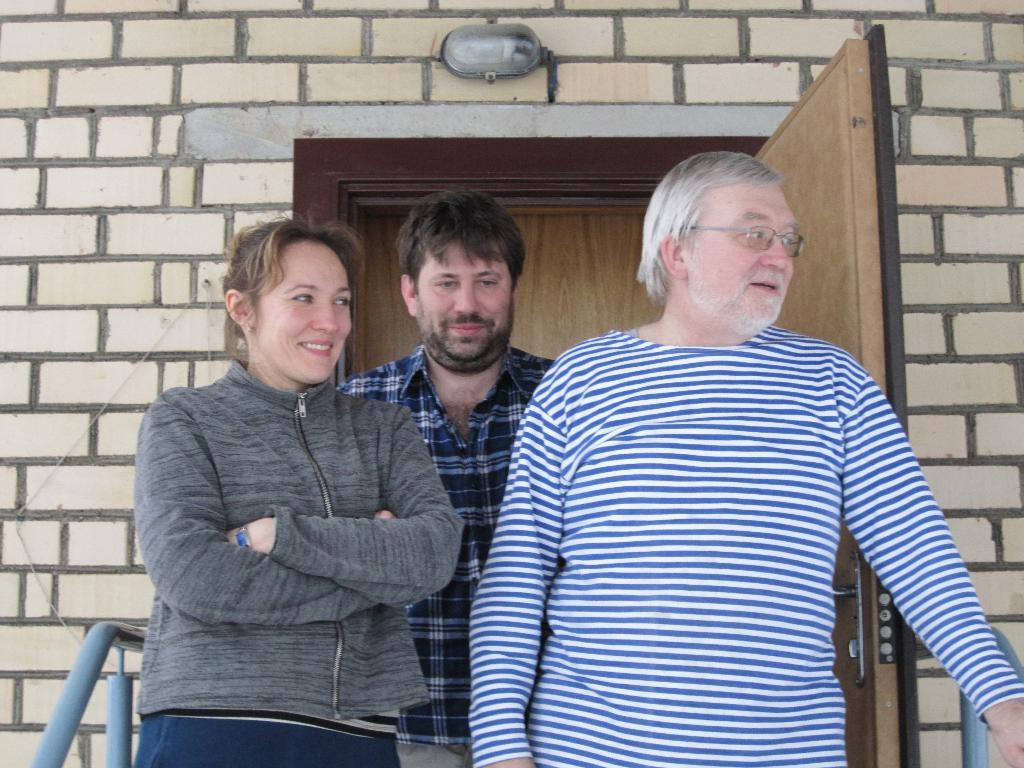How many people are in the image? There are three persons in the image. Can you describe any specific features of one of the persons? One person is wearing specs. What can be seen on the sides of the image? There are handles on the sides. What is the background of the image made of? There is a brick wall in the back. Is there any entrance visible in the brick wall? Yes, the brick wall has a door. What is the source of light in the image? There is a light in the back. How many houses are visible in the image? There are no houses visible in the image; only a brick wall with a door is present. What type of mint is growing near the light in the image? There is no mint present in the image; the light is not associated with any plants or vegetation. 